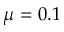Convert formula to latex. <formula><loc_0><loc_0><loc_500><loc_500>\mu = 0 . 1</formula> 